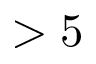Convert formula to latex. <formula><loc_0><loc_0><loc_500><loc_500>> 5</formula> 